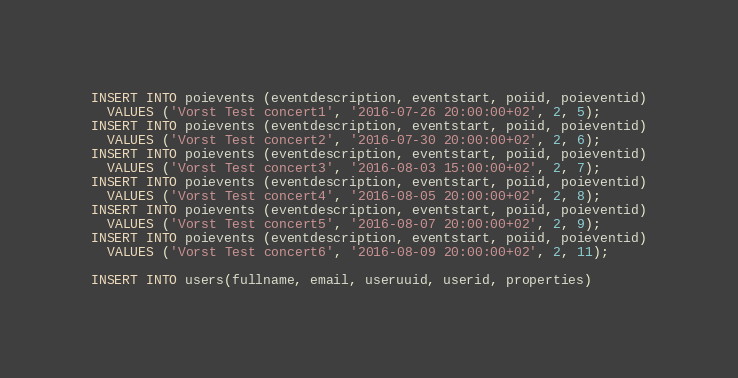<code> <loc_0><loc_0><loc_500><loc_500><_SQL_>INSERT INTO poievents (eventdescription, eventstart, poiid, poieventid)
  VALUES ('Vorst Test concert1', '2016-07-26 20:00:00+02', 2, 5);
INSERT INTO poievents (eventdescription, eventstart, poiid, poieventid)
  VALUES ('Vorst Test concert2', '2016-07-30 20:00:00+02', 2, 6);
INSERT INTO poievents (eventdescription, eventstart, poiid, poieventid)
  VALUES ('Vorst Test concert3', '2016-08-03 15:00:00+02', 2, 7);
INSERT INTO poievents (eventdescription, eventstart, poiid, poieventid)
  VALUES ('Vorst Test concert4', '2016-08-05 20:00:00+02', 2, 8);
INSERT INTO poievents (eventdescription, eventstart, poiid, poieventid)
  VALUES ('Vorst Test concert5', '2016-08-07 20:00:00+02', 2, 9);
INSERT INTO poievents (eventdescription, eventstart, poiid, poieventid)
  VALUES ('Vorst Test concert6', '2016-08-09 20:00:00+02', 2, 11);

INSERT INTO users(fullname, email, useruuid, userid, properties)</code> 